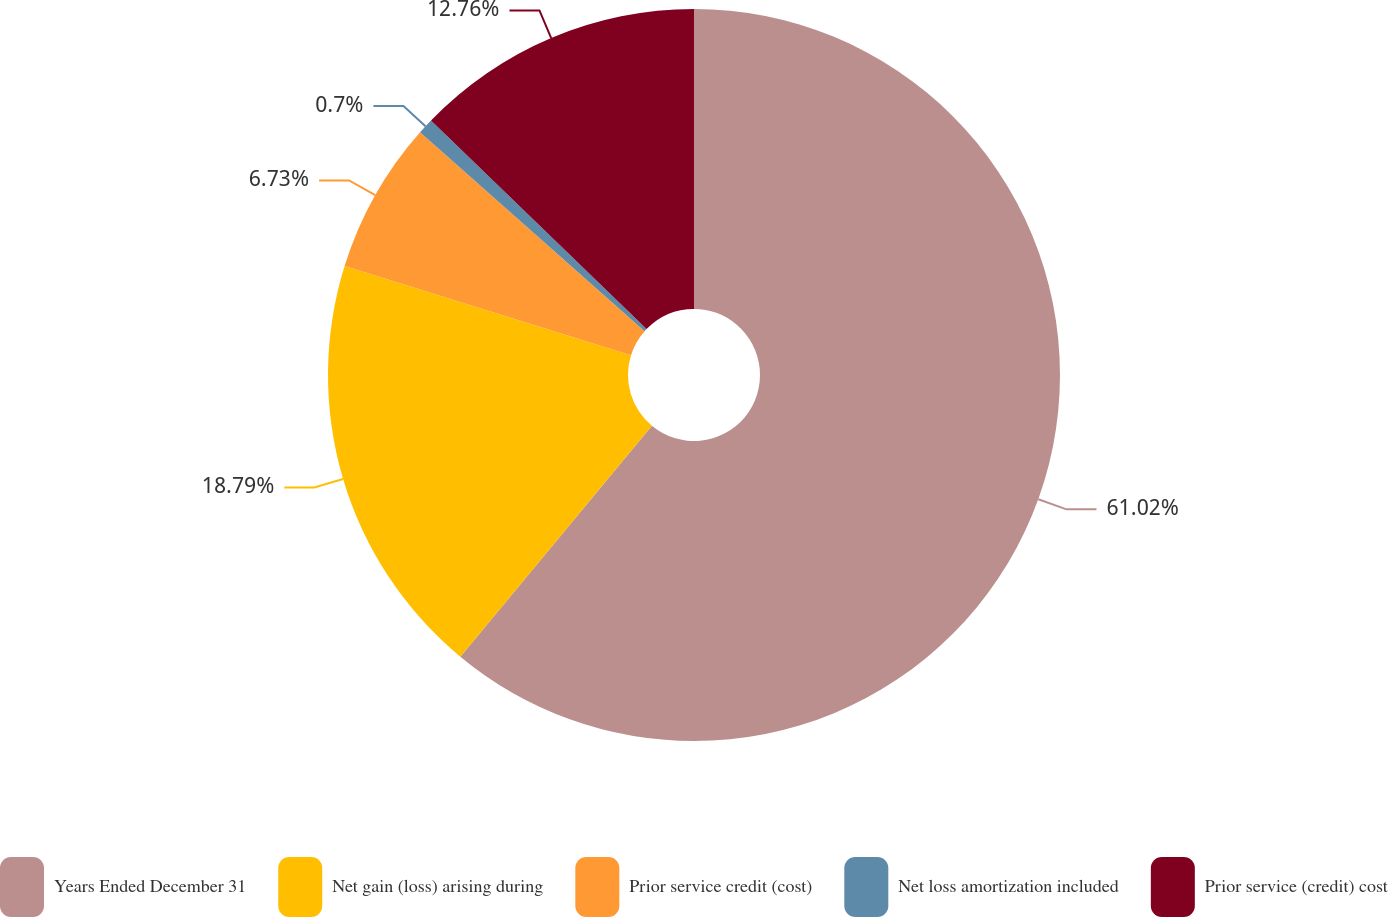Convert chart to OTSL. <chart><loc_0><loc_0><loc_500><loc_500><pie_chart><fcel>Years Ended December 31<fcel>Net gain (loss) arising during<fcel>Prior service credit (cost)<fcel>Net loss amortization included<fcel>Prior service (credit) cost<nl><fcel>61.02%<fcel>18.79%<fcel>6.73%<fcel>0.7%<fcel>12.76%<nl></chart> 